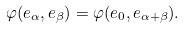Convert formula to latex. <formula><loc_0><loc_0><loc_500><loc_500>\varphi ( e _ { \alpha } , e _ { \beta } ) = \varphi ( e _ { 0 } , e _ { \alpha + \beta } ) .</formula> 